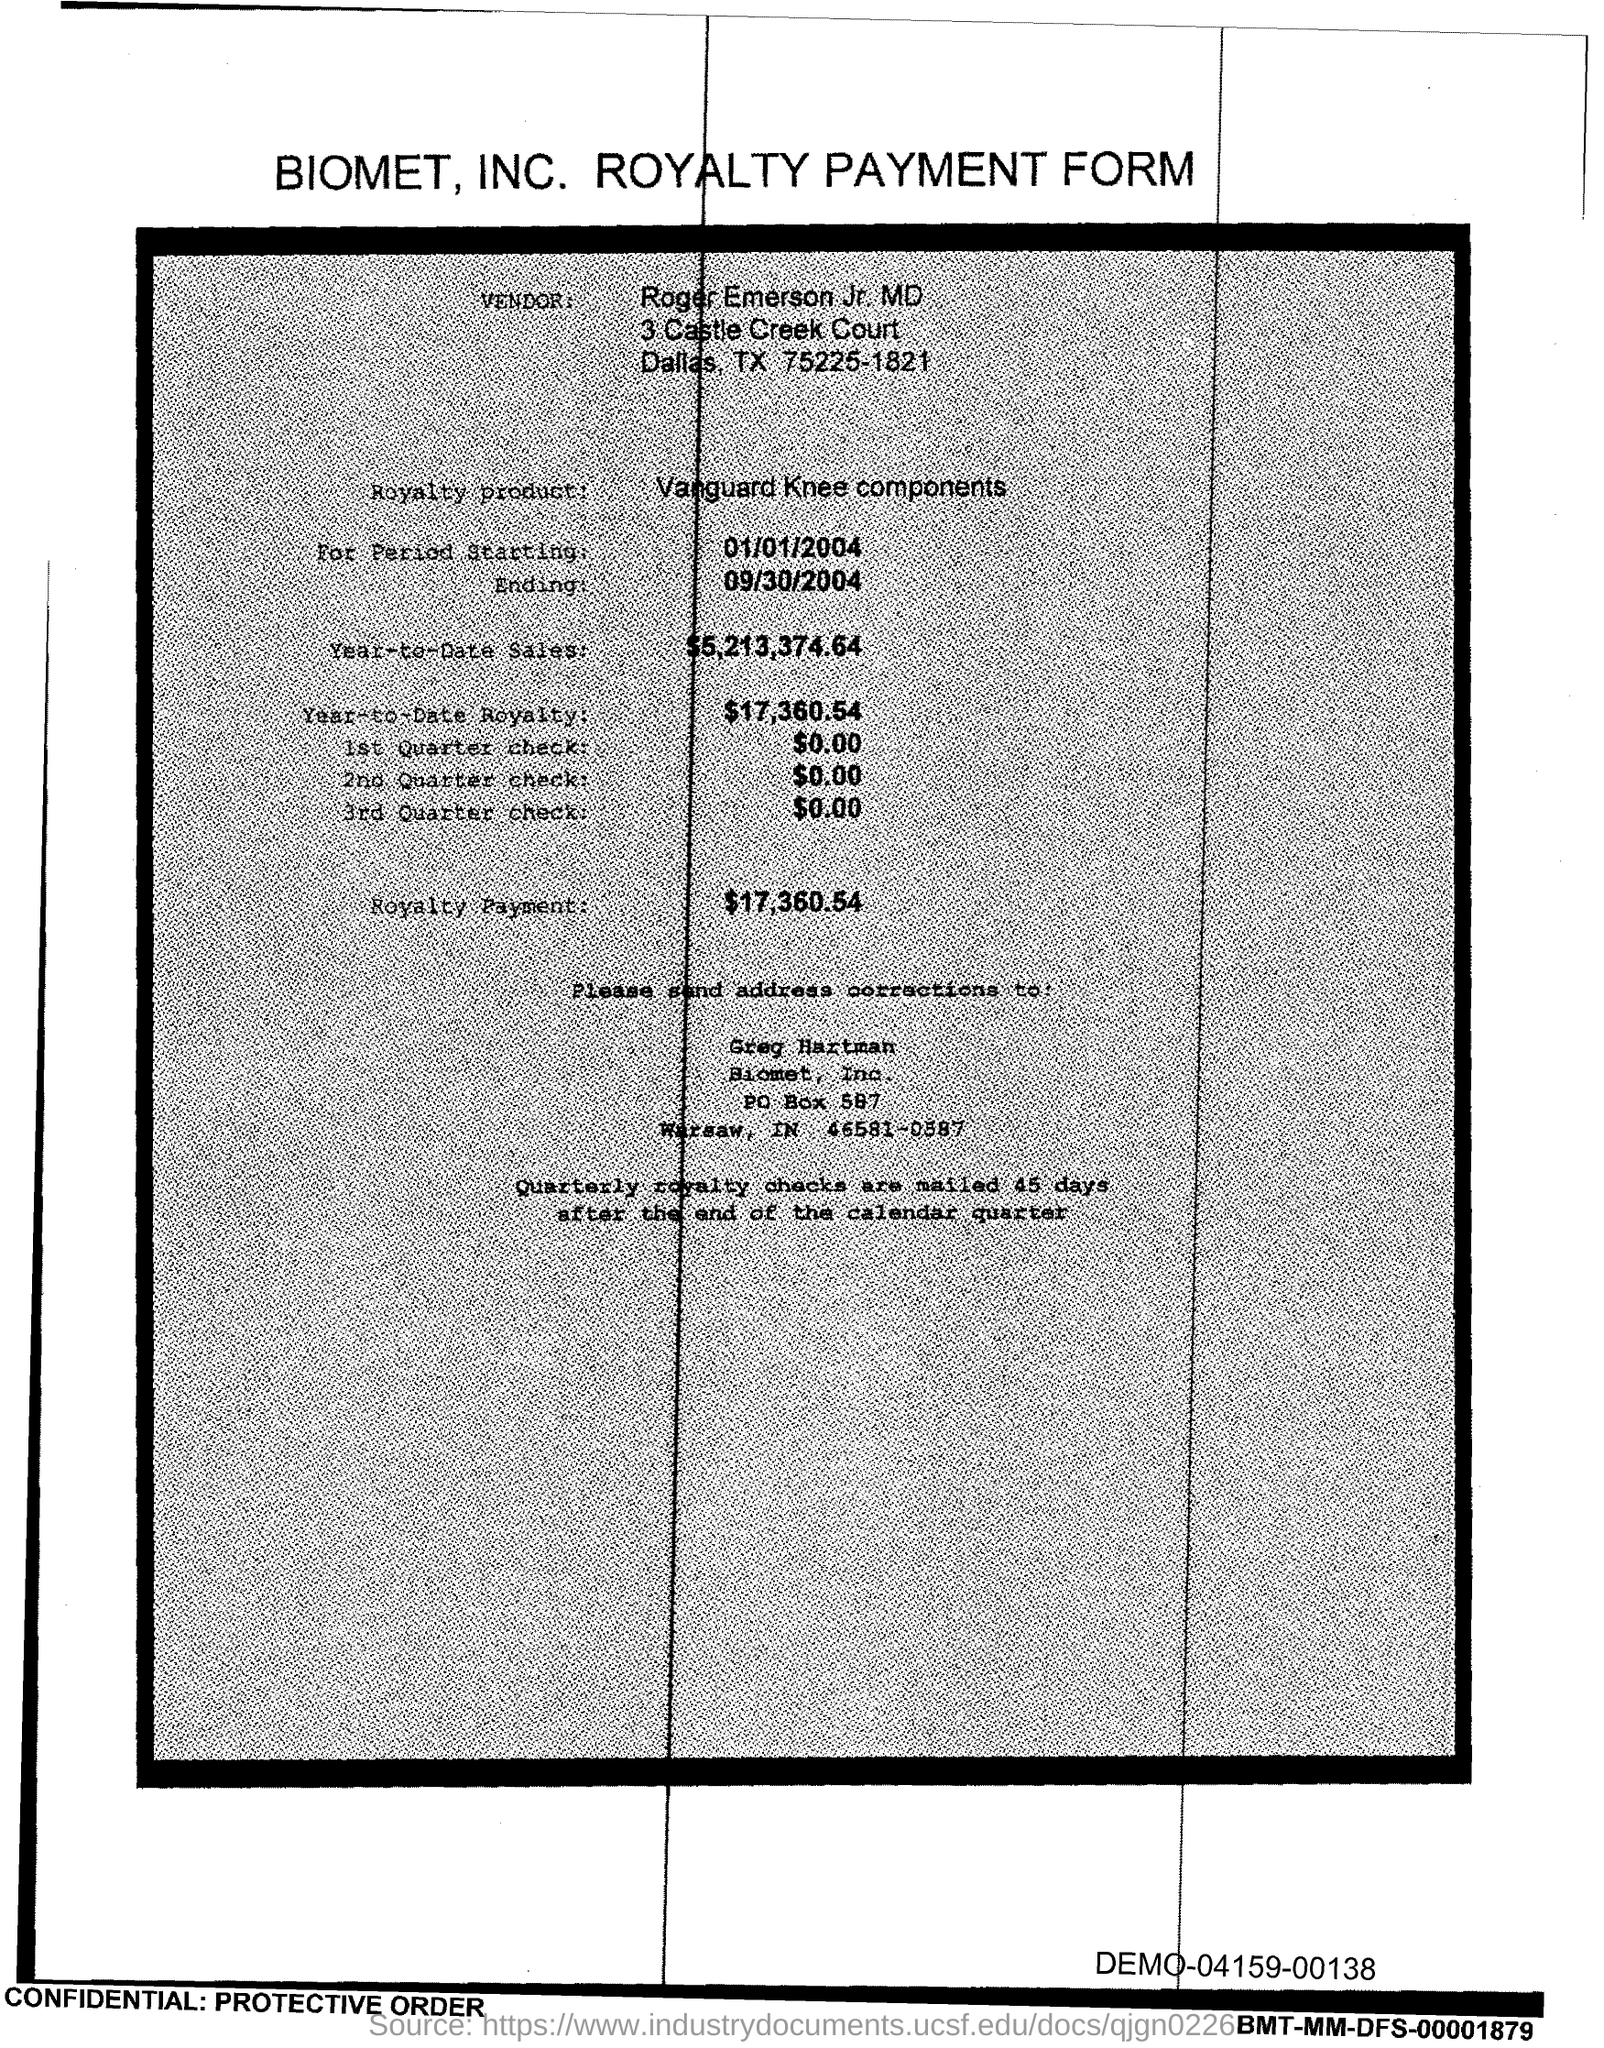Who is the Vendor?
Your answer should be very brief. Roger Emerson Jr. MD. What is the Royalty product?
Your answer should be very brief. Vanguard Knee Components. What is the starting Period?
Offer a terse response. 01/01/2004. What is the ending Period?
Your response must be concise. 09/30/2004. What is the Year-to-Date Royalty?
Your answer should be very brief. $17,360.54. What is the Royalty Payment?
Provide a short and direct response. $17,360.54. Who should the address corrections be sent to?
Ensure brevity in your answer.  Greg Hartman. 